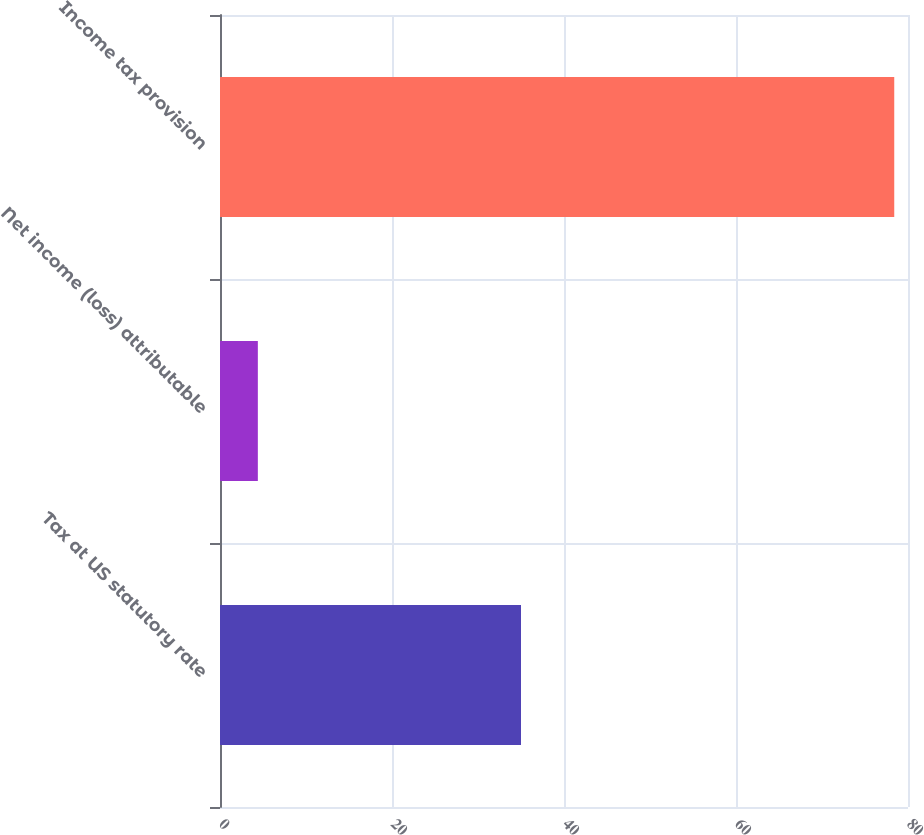Convert chart to OTSL. <chart><loc_0><loc_0><loc_500><loc_500><bar_chart><fcel>Tax at US statutory rate<fcel>Net income (loss) attributable<fcel>Income tax provision<nl><fcel>35<fcel>4.4<fcel>78.4<nl></chart> 